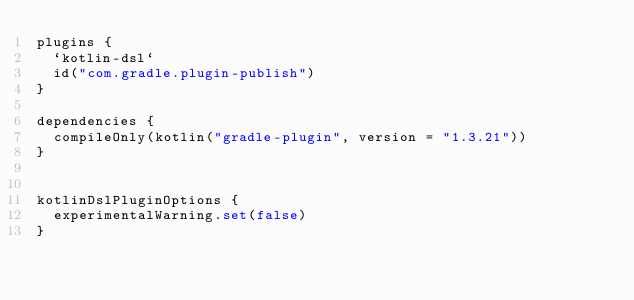<code> <loc_0><loc_0><loc_500><loc_500><_Kotlin_>plugins {
  `kotlin-dsl`
  id("com.gradle.plugin-publish")
}

dependencies {
  compileOnly(kotlin("gradle-plugin", version = "1.3.21"))
}


kotlinDslPluginOptions {
  experimentalWarning.set(false)
}

</code> 